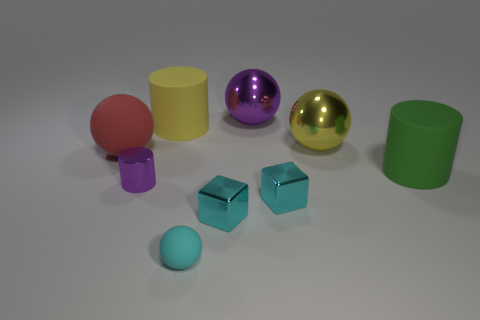Subtract all big red rubber spheres. How many spheres are left? 3 Subtract all cyan spheres. How many spheres are left? 3 Subtract all cubes. How many objects are left? 7 Subtract 2 spheres. How many spheres are left? 2 Add 5 large green objects. How many large green objects exist? 6 Subtract 0 gray cubes. How many objects are left? 9 Subtract all yellow blocks. Subtract all gray cylinders. How many blocks are left? 2 Subtract all purple blocks. How many blue cylinders are left? 0 Subtract all big purple metal spheres. Subtract all tiny shiny objects. How many objects are left? 5 Add 3 red things. How many red things are left? 4 